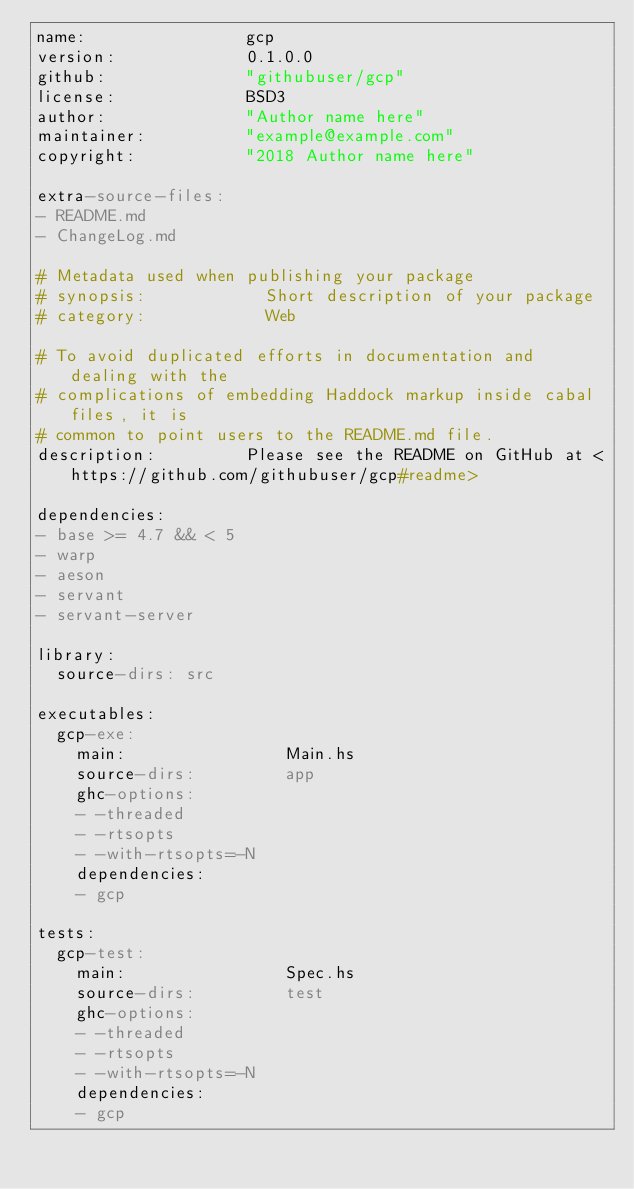Convert code to text. <code><loc_0><loc_0><loc_500><loc_500><_YAML_>name:                gcp
version:             0.1.0.0
github:              "githubuser/gcp"
license:             BSD3
author:              "Author name here"
maintainer:          "example@example.com"
copyright:           "2018 Author name here"

extra-source-files:
- README.md
- ChangeLog.md

# Metadata used when publishing your package
# synopsis:            Short description of your package
# category:            Web

# To avoid duplicated efforts in documentation and dealing with the
# complications of embedding Haddock markup inside cabal files, it is
# common to point users to the README.md file.
description:         Please see the README on GitHub at <https://github.com/githubuser/gcp#readme>

dependencies:
- base >= 4.7 && < 5
- warp
- aeson
- servant
- servant-server

library:
  source-dirs: src

executables:
  gcp-exe:
    main:                Main.hs
    source-dirs:         app
    ghc-options:
    - -threaded
    - -rtsopts
    - -with-rtsopts=-N
    dependencies:
    - gcp

tests:
  gcp-test:
    main:                Spec.hs
    source-dirs:         test
    ghc-options:
    - -threaded
    - -rtsopts
    - -with-rtsopts=-N
    dependencies:
    - gcp
</code> 